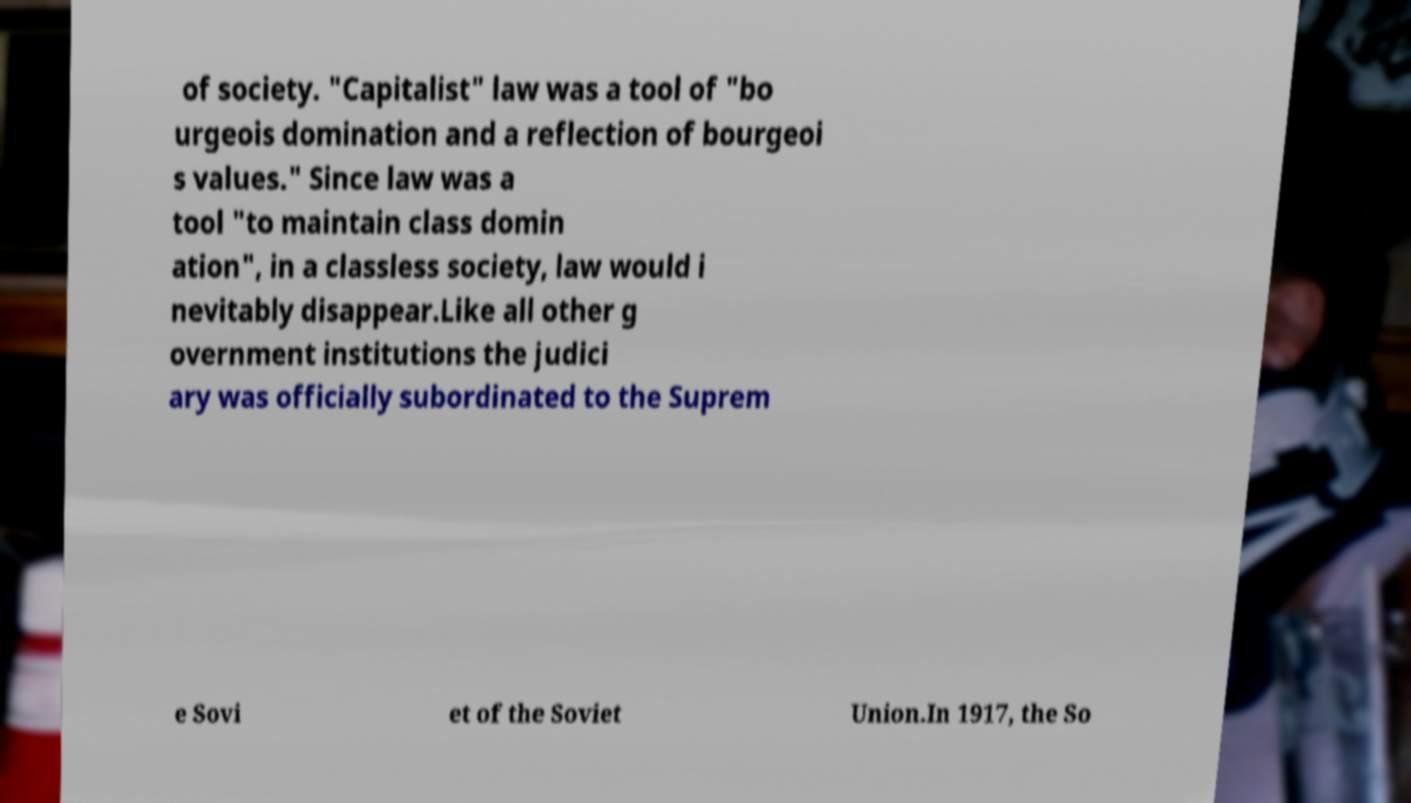For documentation purposes, I need the text within this image transcribed. Could you provide that? of society. "Capitalist" law was a tool of "bo urgeois domination and a reflection of bourgeoi s values." Since law was a tool "to maintain class domin ation", in a classless society, law would i nevitably disappear.Like all other g overnment institutions the judici ary was officially subordinated to the Suprem e Sovi et of the Soviet Union.In 1917, the So 